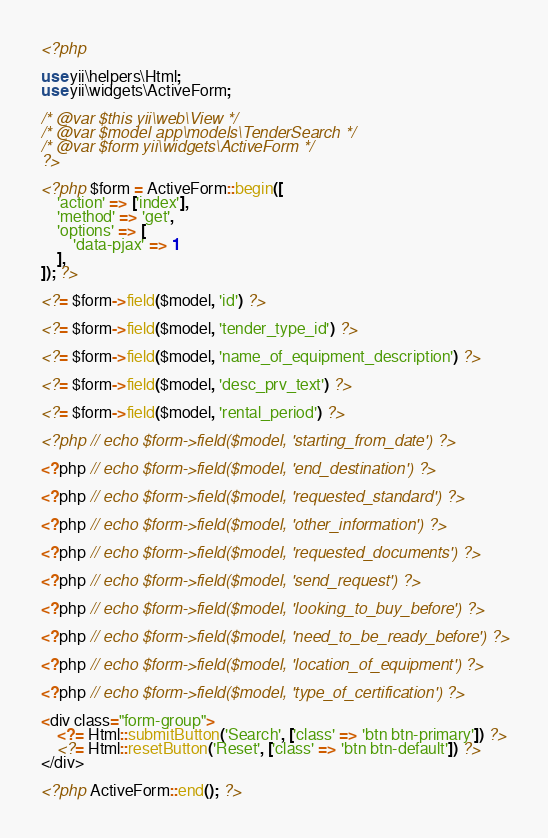<code> <loc_0><loc_0><loc_500><loc_500><_PHP_><?php

use yii\helpers\Html;
use yii\widgets\ActiveForm;

/* @var $this yii\web\View */
/* @var $model app\models\TenderSearch */
/* @var $form yii\widgets\ActiveForm */
?>

<?php $form = ActiveForm::begin([
    'action' => ['index'],
    'method' => 'get',
    'options' => [
        'data-pjax' => 1
    ],
]); ?>

<?= $form->field($model, 'id') ?>

<?= $form->field($model, 'tender_type_id') ?>

<?= $form->field($model, 'name_of_equipment_description') ?>

<?= $form->field($model, 'desc_prv_text') ?>

<?= $form->field($model, 'rental_period') ?>

<?php // echo $form->field($model, 'starting_from_date') ?>

<?php // echo $form->field($model, 'end_destination') ?>

<?php // echo $form->field($model, 'requested_standard') ?>

<?php // echo $form->field($model, 'other_information') ?>

<?php // echo $form->field($model, 'requested_documents') ?>

<?php // echo $form->field($model, 'send_request') ?>

<?php // echo $form->field($model, 'looking_to_buy_before') ?>

<?php // echo $form->field($model, 'need_to_be_ready_before') ?>

<?php // echo $form->field($model, 'location_of_equipment') ?>

<?php // echo $form->field($model, 'type_of_certification') ?>

<div class="form-group">
    <?= Html::submitButton('Search', ['class' => 'btn btn-primary']) ?>
    <?= Html::resetButton('Reset', ['class' => 'btn btn-default']) ?>
</div>

<?php ActiveForm::end(); ?></code> 